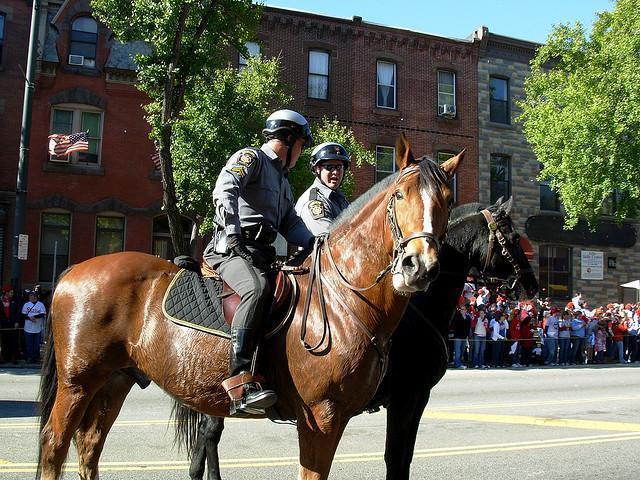How many horses are here?
Give a very brief answer. 2. How many people can you see?
Give a very brief answer. 3. How many horses can be seen?
Give a very brief answer. 2. How many orange cups are on the table?
Give a very brief answer. 0. 